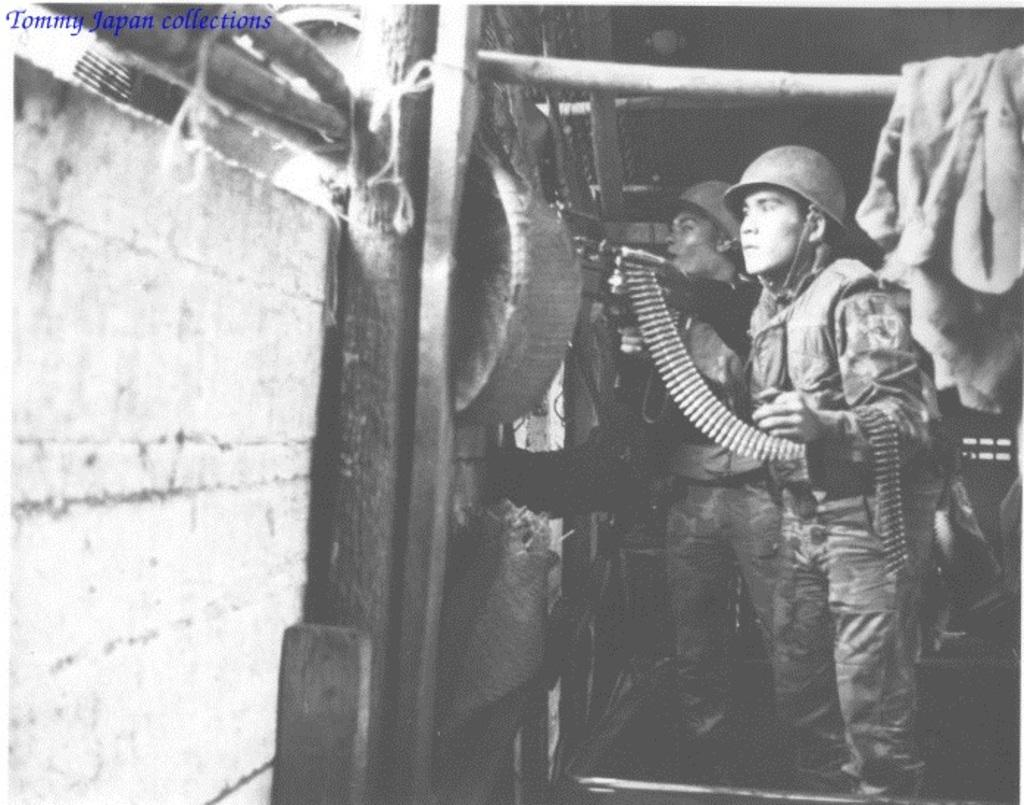What is the color scheme of the image? The image is black and white. Who are the people in the image? There are soldiers in the image. What are the soldiers holding? The soldiers are holding objects. What can be seen in the background of the image? There is a wall in the image, and objects are attached to it. What else is present in the image? There are poles in the image, and objects are on the poles. Can you see a friend of the soldiers playing with a fan in the image? There is no friend or fan present in the image; it features soldiers holding objects and a wall with attached objects. Is there a ball being thrown between the soldiers in the image? There is no ball present in the image; the soldiers are holding objects, but no ball is visible. 